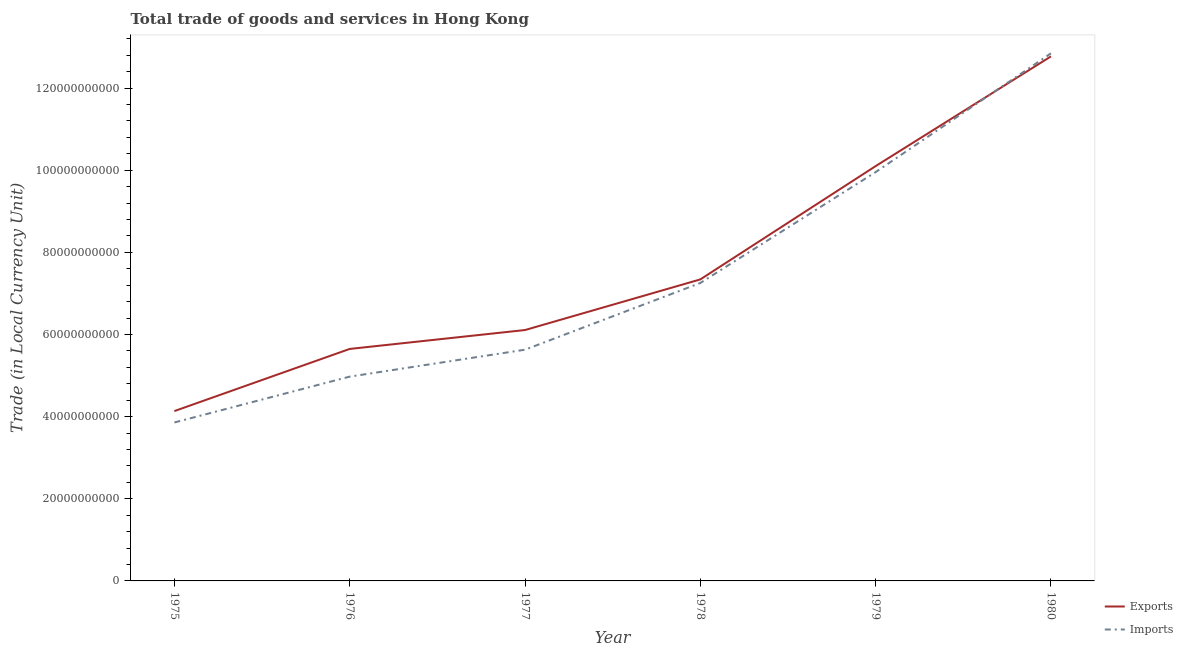How many different coloured lines are there?
Provide a succinct answer. 2. Does the line corresponding to imports of goods and services intersect with the line corresponding to export of goods and services?
Ensure brevity in your answer.  Yes. Is the number of lines equal to the number of legend labels?
Your answer should be very brief. Yes. What is the imports of goods and services in 1976?
Make the answer very short. 4.97e+1. Across all years, what is the maximum export of goods and services?
Offer a terse response. 1.28e+11. Across all years, what is the minimum export of goods and services?
Your answer should be compact. 4.14e+1. In which year was the imports of goods and services maximum?
Ensure brevity in your answer.  1980. In which year was the imports of goods and services minimum?
Your response must be concise. 1975. What is the total imports of goods and services in the graph?
Give a very brief answer. 4.45e+11. What is the difference between the export of goods and services in 1975 and that in 1978?
Provide a succinct answer. -3.21e+1. What is the difference between the export of goods and services in 1979 and the imports of goods and services in 1975?
Give a very brief answer. 6.24e+1. What is the average export of goods and services per year?
Make the answer very short. 7.68e+1. In the year 1979, what is the difference between the imports of goods and services and export of goods and services?
Ensure brevity in your answer.  -1.46e+09. In how many years, is the export of goods and services greater than 16000000000 LCU?
Keep it short and to the point. 6. What is the ratio of the imports of goods and services in 1977 to that in 1980?
Give a very brief answer. 0.44. What is the difference between the highest and the second highest imports of goods and services?
Provide a short and direct response. 2.89e+1. What is the difference between the highest and the lowest export of goods and services?
Provide a succinct answer. 8.64e+1. In how many years, is the export of goods and services greater than the average export of goods and services taken over all years?
Your response must be concise. 2. Is the sum of the export of goods and services in 1975 and 1979 greater than the maximum imports of goods and services across all years?
Provide a short and direct response. Yes. Does the export of goods and services monotonically increase over the years?
Your response must be concise. Yes. Is the imports of goods and services strictly greater than the export of goods and services over the years?
Your answer should be very brief. No. Is the imports of goods and services strictly less than the export of goods and services over the years?
Offer a terse response. No. How many lines are there?
Make the answer very short. 2. Does the graph contain any zero values?
Ensure brevity in your answer.  No. Where does the legend appear in the graph?
Give a very brief answer. Bottom right. How are the legend labels stacked?
Ensure brevity in your answer.  Vertical. What is the title of the graph?
Make the answer very short. Total trade of goods and services in Hong Kong. What is the label or title of the X-axis?
Offer a terse response. Year. What is the label or title of the Y-axis?
Provide a short and direct response. Trade (in Local Currency Unit). What is the Trade (in Local Currency Unit) of Exports in 1975?
Give a very brief answer. 4.14e+1. What is the Trade (in Local Currency Unit) in Imports in 1975?
Your answer should be compact. 3.86e+1. What is the Trade (in Local Currency Unit) of Exports in 1976?
Give a very brief answer. 5.65e+1. What is the Trade (in Local Currency Unit) of Imports in 1976?
Keep it short and to the point. 4.97e+1. What is the Trade (in Local Currency Unit) in Exports in 1977?
Offer a very short reply. 6.11e+1. What is the Trade (in Local Currency Unit) of Imports in 1977?
Make the answer very short. 5.63e+1. What is the Trade (in Local Currency Unit) of Exports in 1978?
Provide a succinct answer. 7.34e+1. What is the Trade (in Local Currency Unit) in Imports in 1978?
Keep it short and to the point. 7.25e+1. What is the Trade (in Local Currency Unit) in Exports in 1979?
Your answer should be very brief. 1.01e+11. What is the Trade (in Local Currency Unit) in Imports in 1979?
Your answer should be compact. 9.96e+1. What is the Trade (in Local Currency Unit) in Exports in 1980?
Provide a succinct answer. 1.28e+11. What is the Trade (in Local Currency Unit) in Imports in 1980?
Provide a short and direct response. 1.28e+11. Across all years, what is the maximum Trade (in Local Currency Unit) of Exports?
Your response must be concise. 1.28e+11. Across all years, what is the maximum Trade (in Local Currency Unit) in Imports?
Offer a terse response. 1.28e+11. Across all years, what is the minimum Trade (in Local Currency Unit) of Exports?
Your answer should be very brief. 4.14e+1. Across all years, what is the minimum Trade (in Local Currency Unit) in Imports?
Offer a very short reply. 3.86e+1. What is the total Trade (in Local Currency Unit) of Exports in the graph?
Offer a very short reply. 4.61e+11. What is the total Trade (in Local Currency Unit) in Imports in the graph?
Provide a succinct answer. 4.45e+11. What is the difference between the Trade (in Local Currency Unit) of Exports in 1975 and that in 1976?
Your response must be concise. -1.51e+1. What is the difference between the Trade (in Local Currency Unit) in Imports in 1975 and that in 1976?
Provide a short and direct response. -1.12e+1. What is the difference between the Trade (in Local Currency Unit) of Exports in 1975 and that in 1977?
Your answer should be compact. -1.97e+1. What is the difference between the Trade (in Local Currency Unit) in Imports in 1975 and that in 1977?
Ensure brevity in your answer.  -1.77e+1. What is the difference between the Trade (in Local Currency Unit) of Exports in 1975 and that in 1978?
Keep it short and to the point. -3.21e+1. What is the difference between the Trade (in Local Currency Unit) in Imports in 1975 and that in 1978?
Offer a very short reply. -3.40e+1. What is the difference between the Trade (in Local Currency Unit) of Exports in 1975 and that in 1979?
Give a very brief answer. -5.96e+1. What is the difference between the Trade (in Local Currency Unit) in Imports in 1975 and that in 1979?
Offer a terse response. -6.10e+1. What is the difference between the Trade (in Local Currency Unit) of Exports in 1975 and that in 1980?
Provide a succinct answer. -8.64e+1. What is the difference between the Trade (in Local Currency Unit) in Imports in 1975 and that in 1980?
Your answer should be compact. -8.99e+1. What is the difference between the Trade (in Local Currency Unit) in Exports in 1976 and that in 1977?
Provide a short and direct response. -4.60e+09. What is the difference between the Trade (in Local Currency Unit) of Imports in 1976 and that in 1977?
Your answer should be compact. -6.56e+09. What is the difference between the Trade (in Local Currency Unit) in Exports in 1976 and that in 1978?
Your answer should be compact. -1.69e+1. What is the difference between the Trade (in Local Currency Unit) of Imports in 1976 and that in 1978?
Make the answer very short. -2.28e+1. What is the difference between the Trade (in Local Currency Unit) in Exports in 1976 and that in 1979?
Provide a short and direct response. -4.45e+1. What is the difference between the Trade (in Local Currency Unit) in Imports in 1976 and that in 1979?
Offer a terse response. -4.98e+1. What is the difference between the Trade (in Local Currency Unit) of Exports in 1976 and that in 1980?
Provide a succinct answer. -7.12e+1. What is the difference between the Trade (in Local Currency Unit) in Imports in 1976 and that in 1980?
Your response must be concise. -7.87e+1. What is the difference between the Trade (in Local Currency Unit) of Exports in 1977 and that in 1978?
Your response must be concise. -1.23e+1. What is the difference between the Trade (in Local Currency Unit) in Imports in 1977 and that in 1978?
Your answer should be very brief. -1.62e+1. What is the difference between the Trade (in Local Currency Unit) of Exports in 1977 and that in 1979?
Ensure brevity in your answer.  -3.99e+1. What is the difference between the Trade (in Local Currency Unit) in Imports in 1977 and that in 1979?
Make the answer very short. -4.32e+1. What is the difference between the Trade (in Local Currency Unit) of Exports in 1977 and that in 1980?
Offer a terse response. -6.66e+1. What is the difference between the Trade (in Local Currency Unit) of Imports in 1977 and that in 1980?
Keep it short and to the point. -7.22e+1. What is the difference between the Trade (in Local Currency Unit) of Exports in 1978 and that in 1979?
Your answer should be compact. -2.76e+1. What is the difference between the Trade (in Local Currency Unit) of Imports in 1978 and that in 1979?
Make the answer very short. -2.70e+1. What is the difference between the Trade (in Local Currency Unit) in Exports in 1978 and that in 1980?
Offer a very short reply. -5.43e+1. What is the difference between the Trade (in Local Currency Unit) in Imports in 1978 and that in 1980?
Ensure brevity in your answer.  -5.59e+1. What is the difference between the Trade (in Local Currency Unit) of Exports in 1979 and that in 1980?
Keep it short and to the point. -2.67e+1. What is the difference between the Trade (in Local Currency Unit) of Imports in 1979 and that in 1980?
Give a very brief answer. -2.89e+1. What is the difference between the Trade (in Local Currency Unit) in Exports in 1975 and the Trade (in Local Currency Unit) in Imports in 1976?
Offer a terse response. -8.39e+09. What is the difference between the Trade (in Local Currency Unit) in Exports in 1975 and the Trade (in Local Currency Unit) in Imports in 1977?
Your response must be concise. -1.49e+1. What is the difference between the Trade (in Local Currency Unit) in Exports in 1975 and the Trade (in Local Currency Unit) in Imports in 1978?
Offer a terse response. -3.12e+1. What is the difference between the Trade (in Local Currency Unit) of Exports in 1975 and the Trade (in Local Currency Unit) of Imports in 1979?
Keep it short and to the point. -5.82e+1. What is the difference between the Trade (in Local Currency Unit) of Exports in 1975 and the Trade (in Local Currency Unit) of Imports in 1980?
Keep it short and to the point. -8.71e+1. What is the difference between the Trade (in Local Currency Unit) of Exports in 1976 and the Trade (in Local Currency Unit) of Imports in 1977?
Keep it short and to the point. 1.85e+08. What is the difference between the Trade (in Local Currency Unit) in Exports in 1976 and the Trade (in Local Currency Unit) in Imports in 1978?
Make the answer very short. -1.61e+1. What is the difference between the Trade (in Local Currency Unit) of Exports in 1976 and the Trade (in Local Currency Unit) of Imports in 1979?
Your response must be concise. -4.31e+1. What is the difference between the Trade (in Local Currency Unit) of Exports in 1976 and the Trade (in Local Currency Unit) of Imports in 1980?
Give a very brief answer. -7.20e+1. What is the difference between the Trade (in Local Currency Unit) in Exports in 1977 and the Trade (in Local Currency Unit) in Imports in 1978?
Your answer should be very brief. -1.15e+1. What is the difference between the Trade (in Local Currency Unit) of Exports in 1977 and the Trade (in Local Currency Unit) of Imports in 1979?
Your response must be concise. -3.85e+1. What is the difference between the Trade (in Local Currency Unit) in Exports in 1977 and the Trade (in Local Currency Unit) in Imports in 1980?
Offer a very short reply. -6.74e+1. What is the difference between the Trade (in Local Currency Unit) of Exports in 1978 and the Trade (in Local Currency Unit) of Imports in 1979?
Your answer should be compact. -2.61e+1. What is the difference between the Trade (in Local Currency Unit) of Exports in 1978 and the Trade (in Local Currency Unit) of Imports in 1980?
Offer a terse response. -5.51e+1. What is the difference between the Trade (in Local Currency Unit) of Exports in 1979 and the Trade (in Local Currency Unit) of Imports in 1980?
Ensure brevity in your answer.  -2.75e+1. What is the average Trade (in Local Currency Unit) of Exports per year?
Keep it short and to the point. 7.68e+1. What is the average Trade (in Local Currency Unit) of Imports per year?
Provide a short and direct response. 7.42e+1. In the year 1975, what is the difference between the Trade (in Local Currency Unit) in Exports and Trade (in Local Currency Unit) in Imports?
Provide a short and direct response. 2.77e+09. In the year 1976, what is the difference between the Trade (in Local Currency Unit) of Exports and Trade (in Local Currency Unit) of Imports?
Your response must be concise. 6.74e+09. In the year 1977, what is the difference between the Trade (in Local Currency Unit) of Exports and Trade (in Local Currency Unit) of Imports?
Offer a terse response. 4.79e+09. In the year 1978, what is the difference between the Trade (in Local Currency Unit) in Exports and Trade (in Local Currency Unit) in Imports?
Make the answer very short. 8.70e+08. In the year 1979, what is the difference between the Trade (in Local Currency Unit) in Exports and Trade (in Local Currency Unit) in Imports?
Make the answer very short. 1.46e+09. In the year 1980, what is the difference between the Trade (in Local Currency Unit) in Exports and Trade (in Local Currency Unit) in Imports?
Provide a succinct answer. -7.42e+08. What is the ratio of the Trade (in Local Currency Unit) in Exports in 1975 to that in 1976?
Ensure brevity in your answer.  0.73. What is the ratio of the Trade (in Local Currency Unit) of Imports in 1975 to that in 1976?
Your answer should be compact. 0.78. What is the ratio of the Trade (in Local Currency Unit) in Exports in 1975 to that in 1977?
Keep it short and to the point. 0.68. What is the ratio of the Trade (in Local Currency Unit) of Imports in 1975 to that in 1977?
Make the answer very short. 0.69. What is the ratio of the Trade (in Local Currency Unit) in Exports in 1975 to that in 1978?
Ensure brevity in your answer.  0.56. What is the ratio of the Trade (in Local Currency Unit) in Imports in 1975 to that in 1978?
Offer a very short reply. 0.53. What is the ratio of the Trade (in Local Currency Unit) in Exports in 1975 to that in 1979?
Offer a terse response. 0.41. What is the ratio of the Trade (in Local Currency Unit) in Imports in 1975 to that in 1979?
Provide a short and direct response. 0.39. What is the ratio of the Trade (in Local Currency Unit) in Exports in 1975 to that in 1980?
Your answer should be compact. 0.32. What is the ratio of the Trade (in Local Currency Unit) of Imports in 1975 to that in 1980?
Offer a very short reply. 0.3. What is the ratio of the Trade (in Local Currency Unit) in Exports in 1976 to that in 1977?
Keep it short and to the point. 0.92. What is the ratio of the Trade (in Local Currency Unit) of Imports in 1976 to that in 1977?
Make the answer very short. 0.88. What is the ratio of the Trade (in Local Currency Unit) in Exports in 1976 to that in 1978?
Offer a very short reply. 0.77. What is the ratio of the Trade (in Local Currency Unit) of Imports in 1976 to that in 1978?
Provide a succinct answer. 0.69. What is the ratio of the Trade (in Local Currency Unit) in Exports in 1976 to that in 1979?
Offer a very short reply. 0.56. What is the ratio of the Trade (in Local Currency Unit) of Imports in 1976 to that in 1979?
Your answer should be very brief. 0.5. What is the ratio of the Trade (in Local Currency Unit) of Exports in 1976 to that in 1980?
Make the answer very short. 0.44. What is the ratio of the Trade (in Local Currency Unit) of Imports in 1976 to that in 1980?
Give a very brief answer. 0.39. What is the ratio of the Trade (in Local Currency Unit) in Exports in 1977 to that in 1978?
Offer a terse response. 0.83. What is the ratio of the Trade (in Local Currency Unit) in Imports in 1977 to that in 1978?
Ensure brevity in your answer.  0.78. What is the ratio of the Trade (in Local Currency Unit) in Exports in 1977 to that in 1979?
Offer a terse response. 0.6. What is the ratio of the Trade (in Local Currency Unit) in Imports in 1977 to that in 1979?
Provide a succinct answer. 0.57. What is the ratio of the Trade (in Local Currency Unit) in Exports in 1977 to that in 1980?
Ensure brevity in your answer.  0.48. What is the ratio of the Trade (in Local Currency Unit) in Imports in 1977 to that in 1980?
Offer a terse response. 0.44. What is the ratio of the Trade (in Local Currency Unit) in Exports in 1978 to that in 1979?
Offer a terse response. 0.73. What is the ratio of the Trade (in Local Currency Unit) of Imports in 1978 to that in 1979?
Provide a succinct answer. 0.73. What is the ratio of the Trade (in Local Currency Unit) of Exports in 1978 to that in 1980?
Offer a terse response. 0.57. What is the ratio of the Trade (in Local Currency Unit) of Imports in 1978 to that in 1980?
Keep it short and to the point. 0.56. What is the ratio of the Trade (in Local Currency Unit) in Exports in 1979 to that in 1980?
Provide a succinct answer. 0.79. What is the ratio of the Trade (in Local Currency Unit) of Imports in 1979 to that in 1980?
Your answer should be compact. 0.77. What is the difference between the highest and the second highest Trade (in Local Currency Unit) of Exports?
Provide a short and direct response. 2.67e+1. What is the difference between the highest and the second highest Trade (in Local Currency Unit) in Imports?
Offer a very short reply. 2.89e+1. What is the difference between the highest and the lowest Trade (in Local Currency Unit) in Exports?
Offer a terse response. 8.64e+1. What is the difference between the highest and the lowest Trade (in Local Currency Unit) in Imports?
Provide a succinct answer. 8.99e+1. 